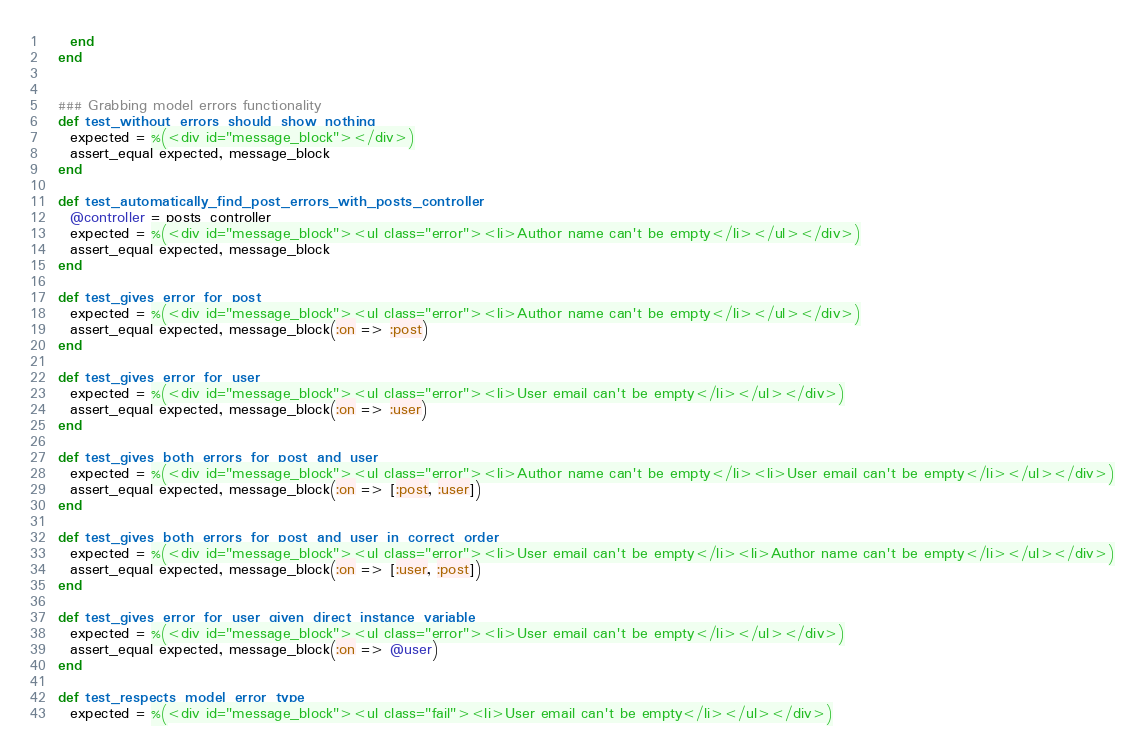<code> <loc_0><loc_0><loc_500><loc_500><_Ruby_>    end
  end
  
  
  ### Grabbing model errors functionality
  def test_without_errors_should_show_nothing
    expected = %(<div id="message_block"></div>)
    assert_equal expected, message_block
  end
  
  def test_automatically_find_post_errors_with_posts_controller
    @controller = posts_controller
    expected = %(<div id="message_block"><ul class="error"><li>Author name can't be empty</li></ul></div>)
    assert_equal expected, message_block
  end
  
  def test_gives_error_for_post
    expected = %(<div id="message_block"><ul class="error"><li>Author name can't be empty</li></ul></div>)
    assert_equal expected, message_block(:on => :post)
  end
  
  def test_gives_error_for_user
    expected = %(<div id="message_block"><ul class="error"><li>User email can't be empty</li></ul></div>)
    assert_equal expected, message_block(:on => :user)
  end
  
  def test_gives_both_errors_for_post_and_user
    expected = %(<div id="message_block"><ul class="error"><li>Author name can't be empty</li><li>User email can't be empty</li></ul></div>)
    assert_equal expected, message_block(:on => [:post, :user])
  end
  
  def test_gives_both_errors_for_post_and_user_in_correct_order
    expected = %(<div id="message_block"><ul class="error"><li>User email can't be empty</li><li>Author name can't be empty</li></ul></div>)
    assert_equal expected, message_block(:on => [:user, :post])
  end
  
  def test_gives_error_for_user_given_direct_instance_variable
    expected = %(<div id="message_block"><ul class="error"><li>User email can't be empty</li></ul></div>)
    assert_equal expected, message_block(:on => @user)
  end
  
  def test_respects_model_error_type
    expected = %(<div id="message_block"><ul class="fail"><li>User email can't be empty</li></ul></div>)</code> 